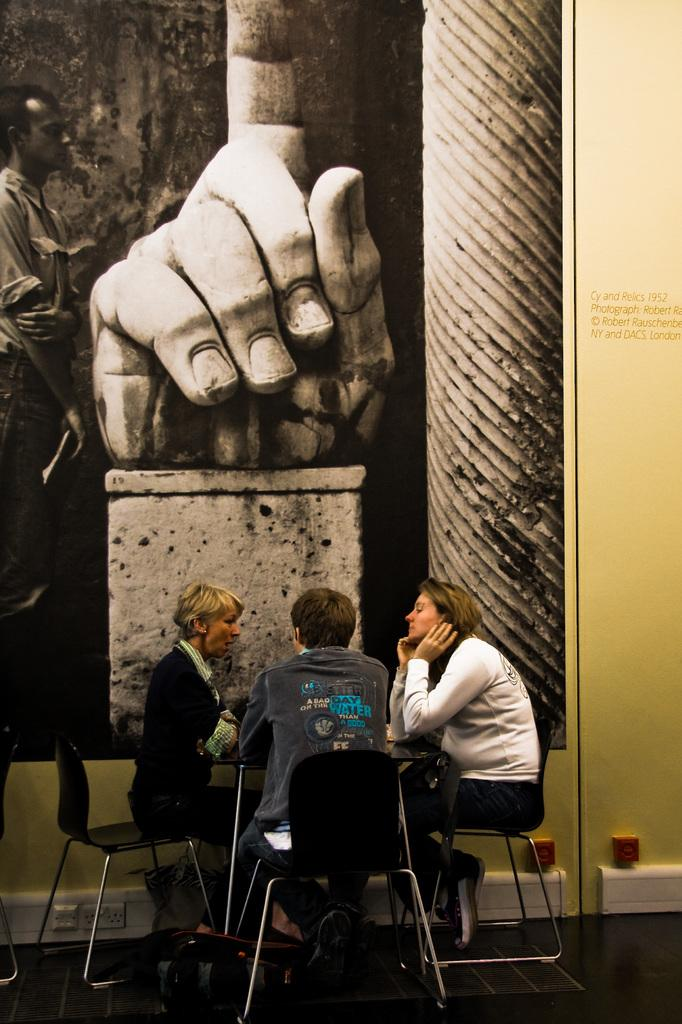How many persons are in the image? There are three persons in the image. What are the persons doing in the image? The persons are sitting in a chair. What is in front of the persons? There is a table in front of the persons. Are the persons in the image sleeping or seeking approval? There is no indication in the image that the persons are sleeping or seeking approval. Can you tell me how many keys are visible on the table in the image? There is no mention of any keys present on the table in the image. 